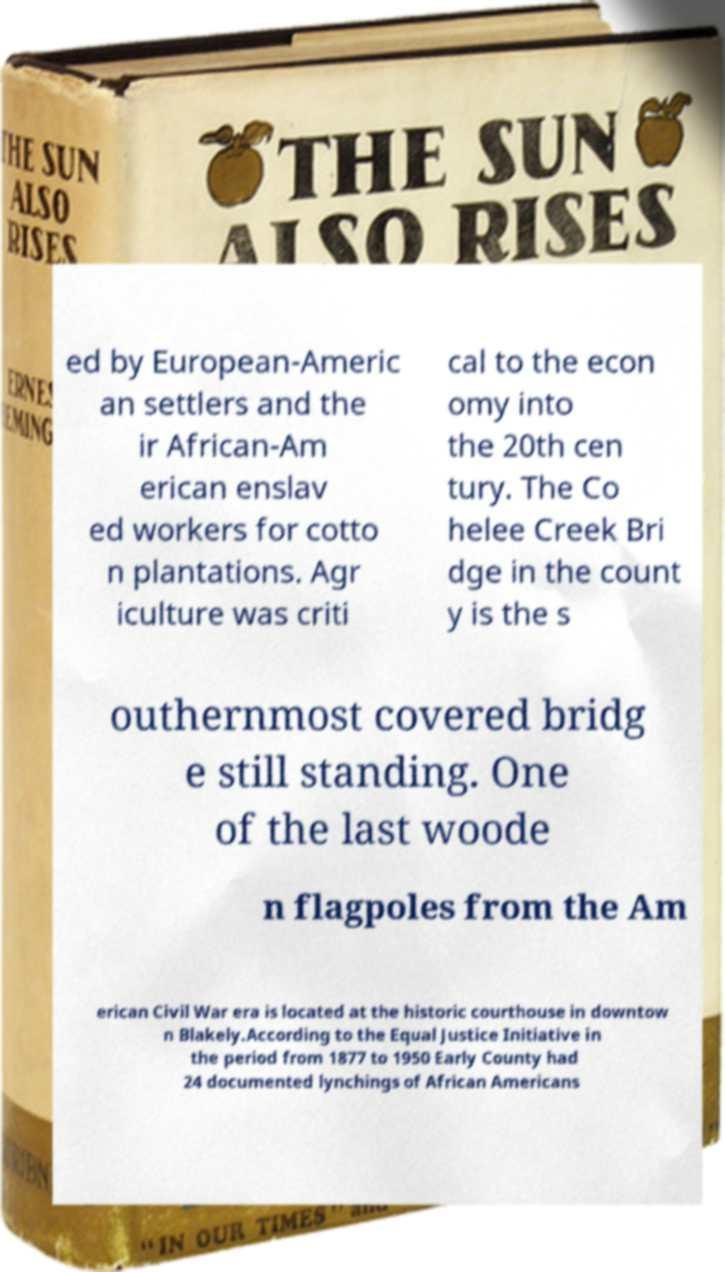What messages or text are displayed in this image? I need them in a readable, typed format. ed by European-Americ an settlers and the ir African-Am erican enslav ed workers for cotto n plantations. Agr iculture was criti cal to the econ omy into the 20th cen tury. The Co helee Creek Bri dge in the count y is the s outhernmost covered bridg e still standing. One of the last woode n flagpoles from the Am erican Civil War era is located at the historic courthouse in downtow n Blakely.According to the Equal Justice Initiative in the period from 1877 to 1950 Early County had 24 documented lynchings of African Americans 